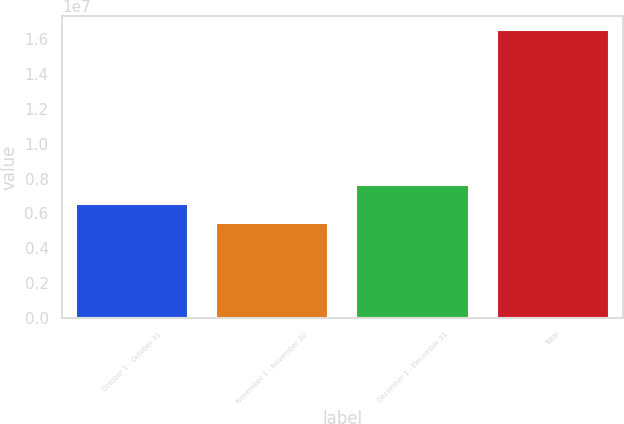<chart> <loc_0><loc_0><loc_500><loc_500><bar_chart><fcel>October 1 - October 31<fcel>November 1 - November 30<fcel>December 1 - December 31<fcel>Total<nl><fcel>6.55472e+06<fcel>5.4478e+06<fcel>7.66164e+06<fcel>1.6517e+07<nl></chart> 